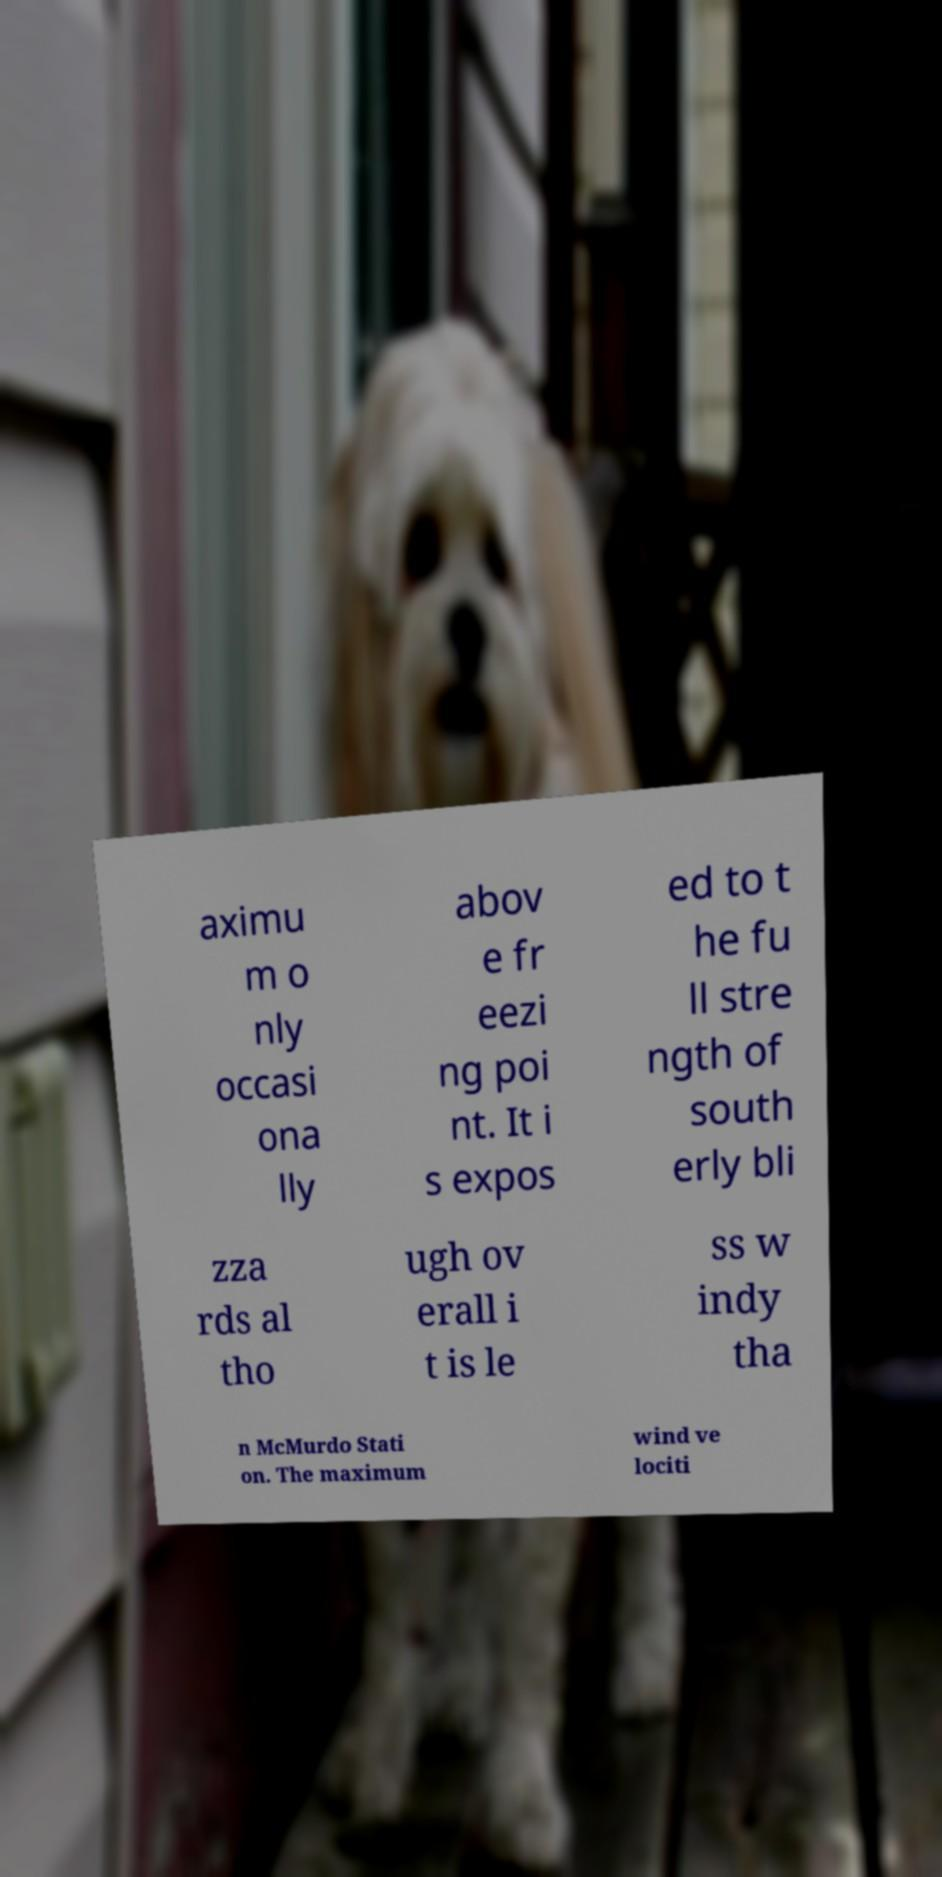Could you extract and type out the text from this image? aximu m o nly occasi ona lly abov e fr eezi ng poi nt. It i s expos ed to t he fu ll stre ngth of south erly bli zza rds al tho ugh ov erall i t is le ss w indy tha n McMurdo Stati on. The maximum wind ve lociti 